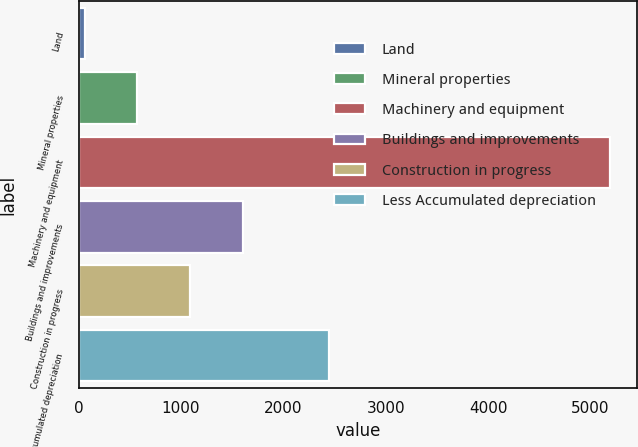Convert chart to OTSL. <chart><loc_0><loc_0><loc_500><loc_500><bar_chart><fcel>Land<fcel>Mineral properties<fcel>Machinery and equipment<fcel>Buildings and improvements<fcel>Construction in progress<fcel>Less Accumulated depreciation<nl><fcel>60.3<fcel>573.88<fcel>5196.1<fcel>1601.04<fcel>1087.46<fcel>2447.5<nl></chart> 